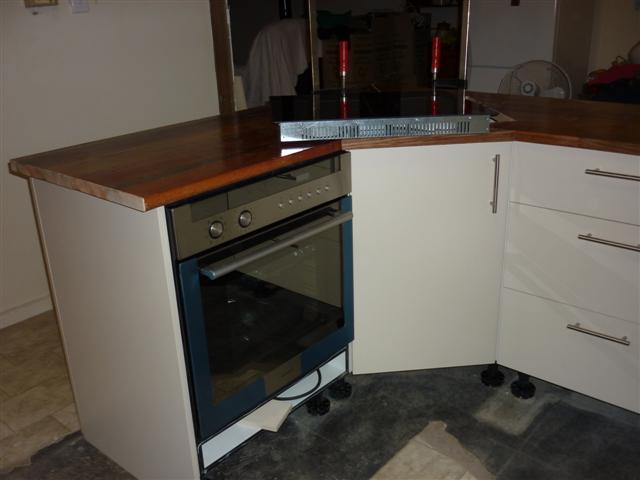How many candles are in this scene?
Give a very brief answer. 2. 